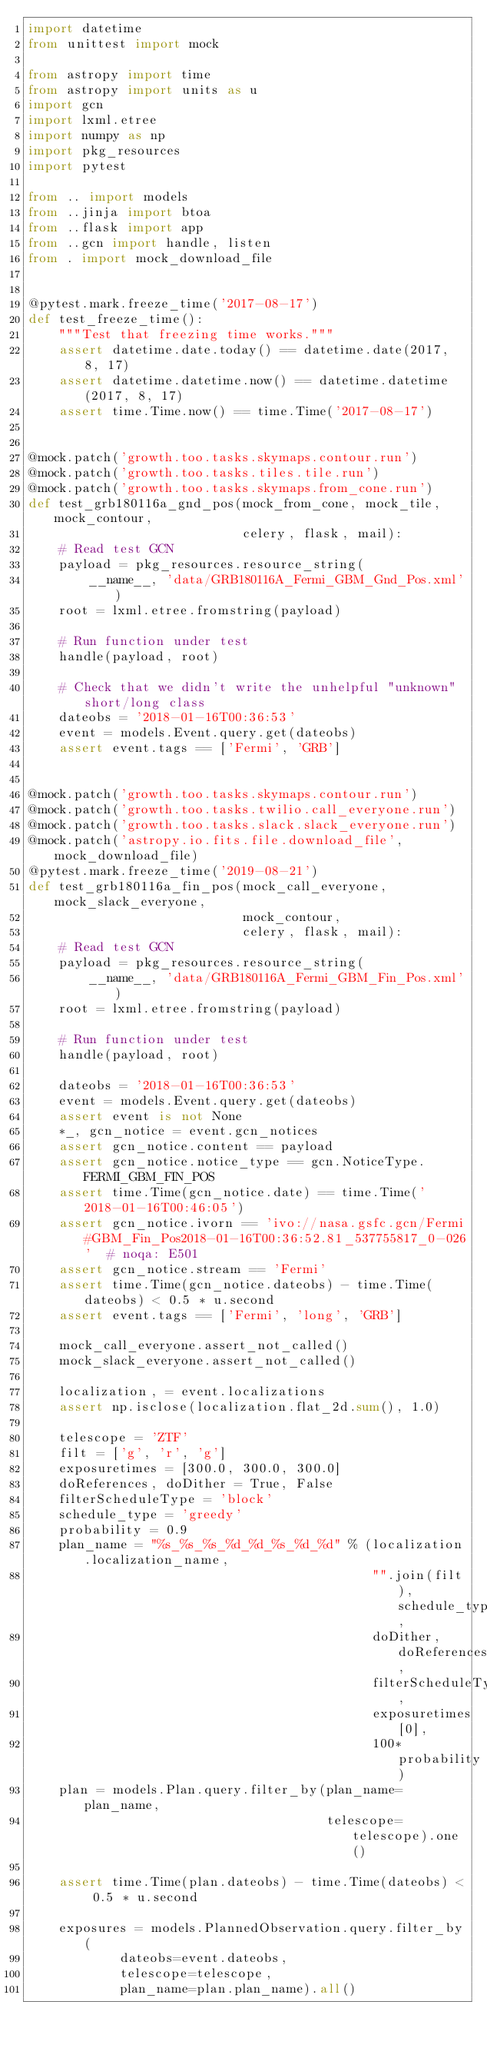<code> <loc_0><loc_0><loc_500><loc_500><_Python_>import datetime
from unittest import mock

from astropy import time
from astropy import units as u
import gcn
import lxml.etree
import numpy as np
import pkg_resources
import pytest

from .. import models
from ..jinja import btoa
from ..flask import app
from ..gcn import handle, listen
from . import mock_download_file


@pytest.mark.freeze_time('2017-08-17')
def test_freeze_time():
    """Test that freezing time works."""
    assert datetime.date.today() == datetime.date(2017, 8, 17)
    assert datetime.datetime.now() == datetime.datetime(2017, 8, 17)
    assert time.Time.now() == time.Time('2017-08-17')


@mock.patch('growth.too.tasks.skymaps.contour.run')
@mock.patch('growth.too.tasks.tiles.tile.run')
@mock.patch('growth.too.tasks.skymaps.from_cone.run')
def test_grb180116a_gnd_pos(mock_from_cone, mock_tile, mock_contour,
                            celery, flask, mail):
    # Read test GCN
    payload = pkg_resources.resource_string(
        __name__, 'data/GRB180116A_Fermi_GBM_Gnd_Pos.xml')
    root = lxml.etree.fromstring(payload)

    # Run function under test
    handle(payload, root)

    # Check that we didn't write the unhelpful "unknown" short/long class
    dateobs = '2018-01-16T00:36:53'
    event = models.Event.query.get(dateobs)
    assert event.tags == ['Fermi', 'GRB']


@mock.patch('growth.too.tasks.skymaps.contour.run')
@mock.patch('growth.too.tasks.twilio.call_everyone.run')
@mock.patch('growth.too.tasks.slack.slack_everyone.run')
@mock.patch('astropy.io.fits.file.download_file', mock_download_file)
@pytest.mark.freeze_time('2019-08-21')
def test_grb180116a_fin_pos(mock_call_everyone, mock_slack_everyone,
                            mock_contour,
                            celery, flask, mail):
    # Read test GCN
    payload = pkg_resources.resource_string(
        __name__, 'data/GRB180116A_Fermi_GBM_Fin_Pos.xml')
    root = lxml.etree.fromstring(payload)

    # Run function under test
    handle(payload, root)

    dateobs = '2018-01-16T00:36:53'
    event = models.Event.query.get(dateobs)
    assert event is not None
    *_, gcn_notice = event.gcn_notices
    assert gcn_notice.content == payload
    assert gcn_notice.notice_type == gcn.NoticeType.FERMI_GBM_FIN_POS
    assert time.Time(gcn_notice.date) == time.Time('2018-01-16T00:46:05')
    assert gcn_notice.ivorn == 'ivo://nasa.gsfc.gcn/Fermi#GBM_Fin_Pos2018-01-16T00:36:52.81_537755817_0-026'  # noqa: E501
    assert gcn_notice.stream == 'Fermi'
    assert time.Time(gcn_notice.dateobs) - time.Time(dateobs) < 0.5 * u.second
    assert event.tags == ['Fermi', 'long', 'GRB']

    mock_call_everyone.assert_not_called()
    mock_slack_everyone.assert_not_called()

    localization, = event.localizations
    assert np.isclose(localization.flat_2d.sum(), 1.0)

    telescope = 'ZTF'
    filt = ['g', 'r', 'g']
    exposuretimes = [300.0, 300.0, 300.0]
    doReferences, doDither = True, False
    filterScheduleType = 'block'
    schedule_type = 'greedy'
    probability = 0.9
    plan_name = "%s_%s_%s_%d_%d_%s_%d_%d" % (localization.localization_name,
                                             "".join(filt), schedule_type,
                                             doDither, doReferences,
                                             filterScheduleType,
                                             exposuretimes[0],
                                             100*probability)
    plan = models.Plan.query.filter_by(plan_name=plan_name,
                                       telescope=telescope).one()

    assert time.Time(plan.dateobs) - time.Time(dateobs) < 0.5 * u.second

    exposures = models.PlannedObservation.query.filter_by(
            dateobs=event.dateobs,
            telescope=telescope,
            plan_name=plan.plan_name).all()
</code> 